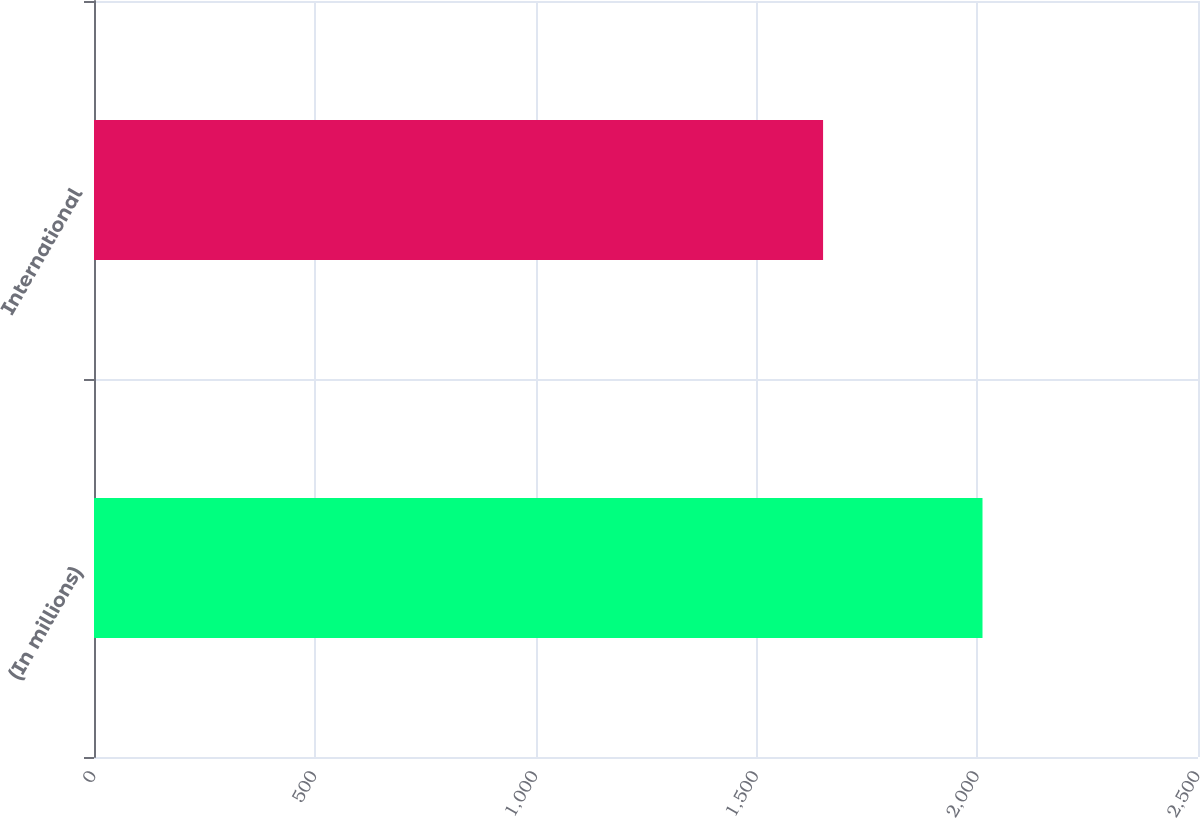<chart> <loc_0><loc_0><loc_500><loc_500><bar_chart><fcel>(In millions)<fcel>International<nl><fcel>2012<fcel>1651<nl></chart> 